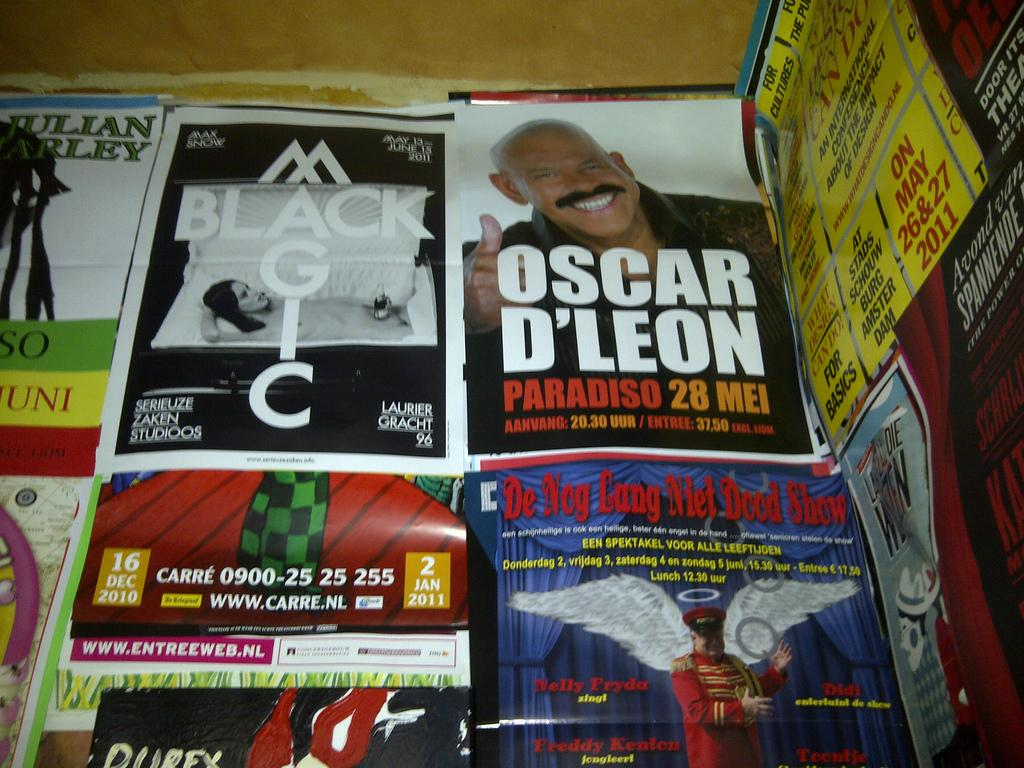Provide a one-sentence caption for the provided image. Posters for several different shows overlap one another, including Black Magic. 